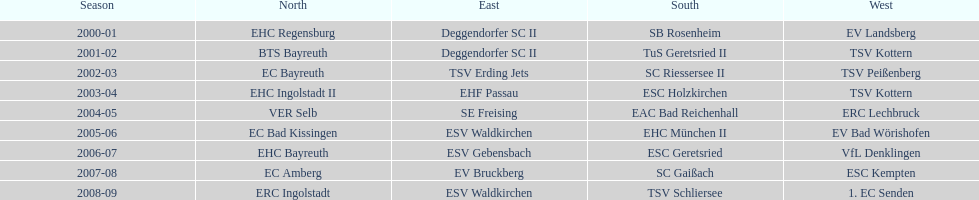Starting with the 2007 - 08 season, does ecs kempten appear in any of the previous years? No. 